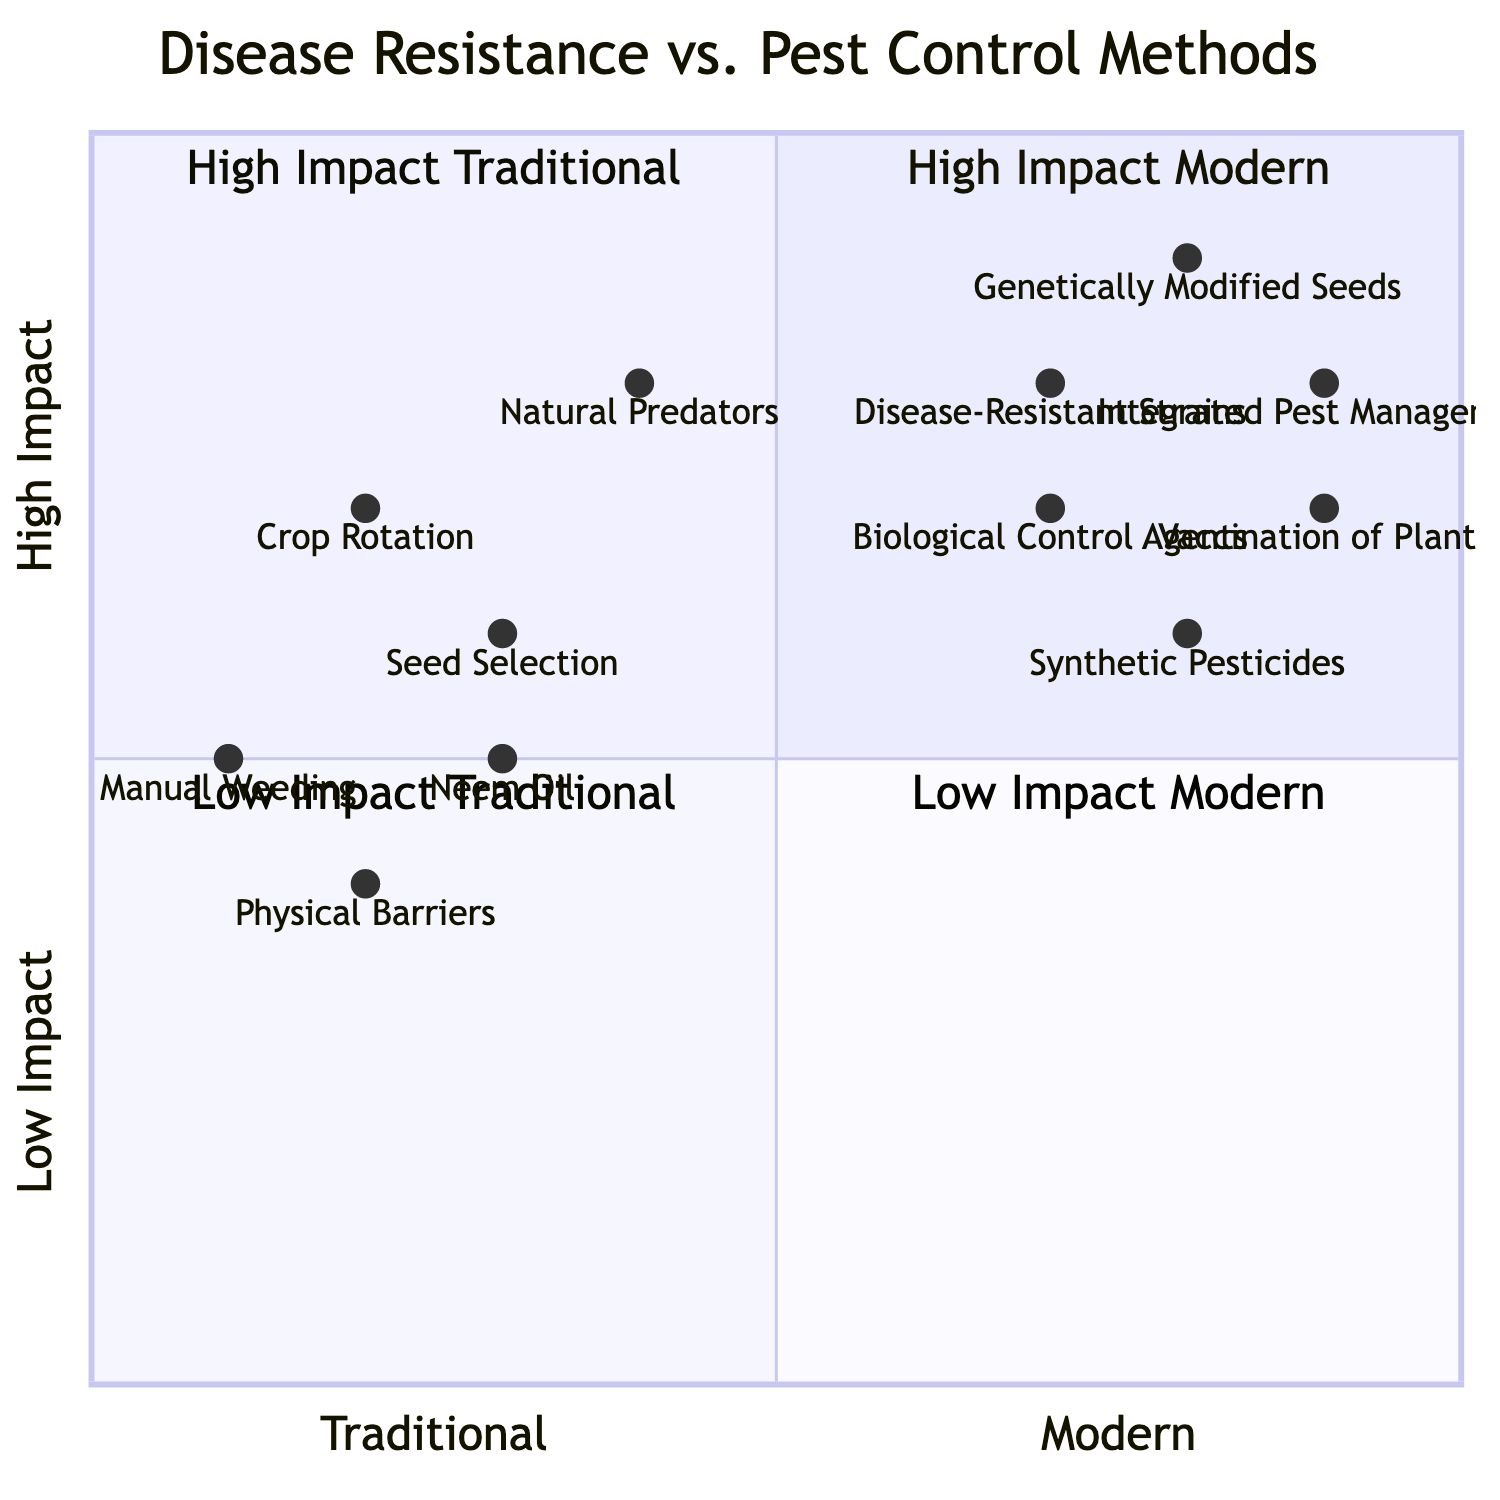What are the two High Impact Traditional methods in the diagram? The diagram specifies that the High Impact Traditional methods are Natural Predators and Seed Selection, which are positioned in quadrant 2 of the chart.
Answer: Natural Predators, Seed Selection Which pest control method has the highest impact in the modern approach? In the diagram, Integrated Pest Management is situated in quadrant 1, indicating it has the highest impact among modern pest control methods.
Answer: Integrated Pest Management How many methods are categorized under Low Impact Traditional? The diagram shows three methods falling under Low Impact Traditional in quadrant 3: Manual Weeding, Physical Barriers, and Neem Oil.
Answer: Three What is the y-coordinate for Disease-Resistant Strains? Upon examining the coordinates of Disease-Resistant Strains in the diagram, it shows a y-coordinate value of 0.8, indicating its position in terms of impact on the chart.
Answer: 0.8 What relationship does Crop Rotation have with Synthetic Pesticides? In the context of the diagram, Crop Rotation (0.2, 0.7) is in quadrant 2 while Synthetic Pesticides (0.8, 0.6) is in quadrant 1, demonstrating that the former has a lower overall impact compared to the latter.
Answer: Lower impact Which Disease Resistance method has the highest y-coordinate value? The chart indicates that Vaccination of Plants has the highest y-coordinate value at 0.9, representing its strong impact in terms of disease resistance.
Answer: Vaccination of Plants Which quadrant contains the most pest control methods? Upon inspection of the diagram, quadrant 4 (Low Impact Modern) has three pest control methods: Synthetic Pesticides, Biological Control Agents, and Integrated Pest Management, indicating it holds more complexity.
Answer: Quadrant 4 What is the x-coordinate of Neem Oil? In the diagram, Neem Oil is placed at an x-coordinate value of 0.3, reflecting its classification under traditional pest control methods.
Answer: 0.3 